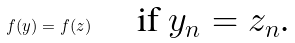Convert formula to latex. <formula><loc_0><loc_0><loc_500><loc_500>f ( y ) = f ( z ) \quad \text { if $y_{n}=z_{n}$.}</formula> 